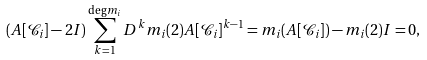<formula> <loc_0><loc_0><loc_500><loc_500>( A [ \mathcal { C } _ { i } ] - 2 I ) \sum _ { k = 1 } ^ { \deg m _ { i } } D ^ { k } m _ { i } ( 2 ) A [ \mathcal { C } _ { i } ] ^ { k - 1 } = m _ { i } ( A [ \mathcal { C } _ { i } ] ) - m _ { i } ( 2 ) I = 0 ,</formula> 